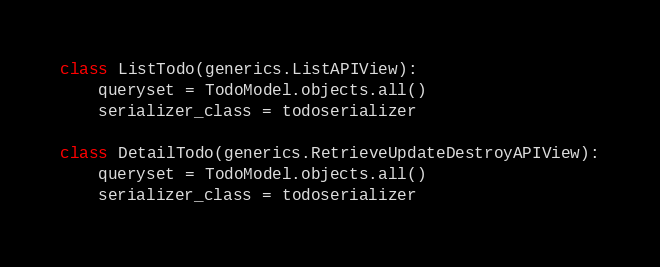<code> <loc_0><loc_0><loc_500><loc_500><_Python_>
class ListTodo(generics.ListAPIView):
    queryset = TodoModel.objects.all()
    serializer_class = todoserializer

class DetailTodo(generics.RetrieveUpdateDestroyAPIView):
    queryset = TodoModel.objects.all()
    serializer_class = todoserializer
</code> 